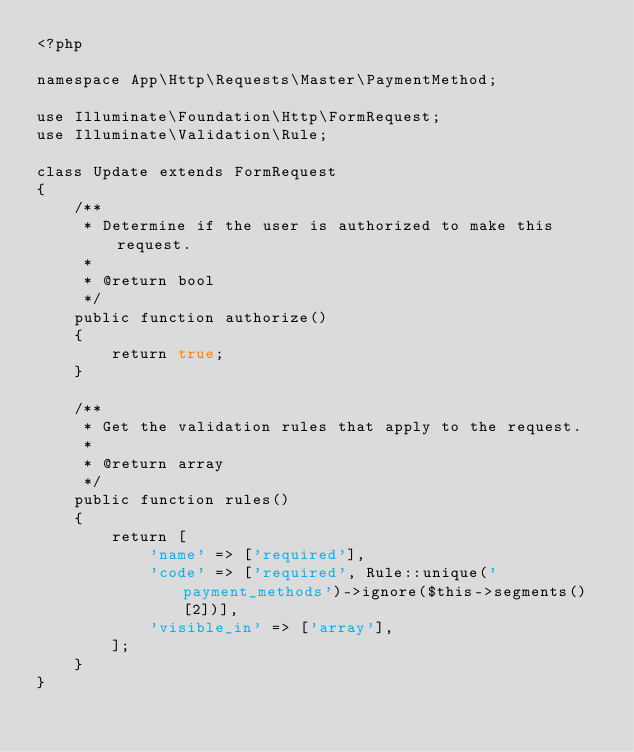Convert code to text. <code><loc_0><loc_0><loc_500><loc_500><_PHP_><?php

namespace App\Http\Requests\Master\PaymentMethod;

use Illuminate\Foundation\Http\FormRequest;
use Illuminate\Validation\Rule;

class Update extends FormRequest
{
    /**
     * Determine if the user is authorized to make this request.
     *
     * @return bool
     */
    public function authorize()
    {
        return true;
    }

    /**
     * Get the validation rules that apply to the request.
     *
     * @return array
     */
    public function rules()
    {
        return [
            'name' => ['required'],
            'code' => ['required', Rule::unique('payment_methods')->ignore($this->segments()[2])],
            'visible_in' => ['array'],
        ];
    }
}
</code> 